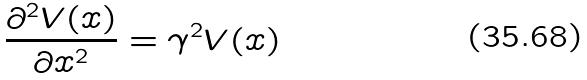<formula> <loc_0><loc_0><loc_500><loc_500>\frac { \partial ^ { 2 } V ( x ) } { \partial x ^ { 2 } } = \gamma ^ { 2 } V ( x )</formula> 